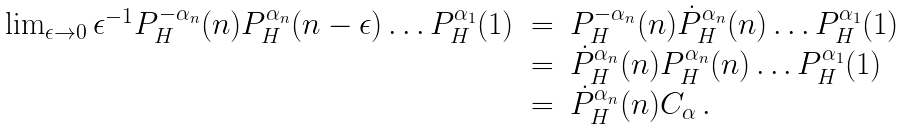<formula> <loc_0><loc_0><loc_500><loc_500>\begin{array} { r c l } \lim _ { \epsilon \to 0 } \epsilon ^ { - 1 } P _ { H } ^ { - \alpha _ { n } } ( n ) P _ { H } ^ { \alpha _ { n } } ( n - \epsilon ) \dots P _ { H } ^ { \alpha _ { 1 } } ( 1 ) & = & P _ { H } ^ { - \alpha _ { n } } ( n ) \dot { P } _ { H } ^ { \alpha _ { n } } ( n ) \dots P _ { H } ^ { \alpha _ { 1 } } ( 1 ) \\ & = & \dot { P } _ { H } ^ { \alpha _ { n } } ( n ) P _ { H } ^ { \alpha _ { n } } ( n ) \dots P _ { H } ^ { \alpha _ { 1 } } ( 1 ) \\ & = & \dot { P } _ { H } ^ { \alpha _ { n } } ( n ) C _ { \alpha } \, . \end{array}</formula> 